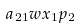<formula> <loc_0><loc_0><loc_500><loc_500>a _ { 2 1 } w x _ { 1 } p _ { 2 }</formula> 